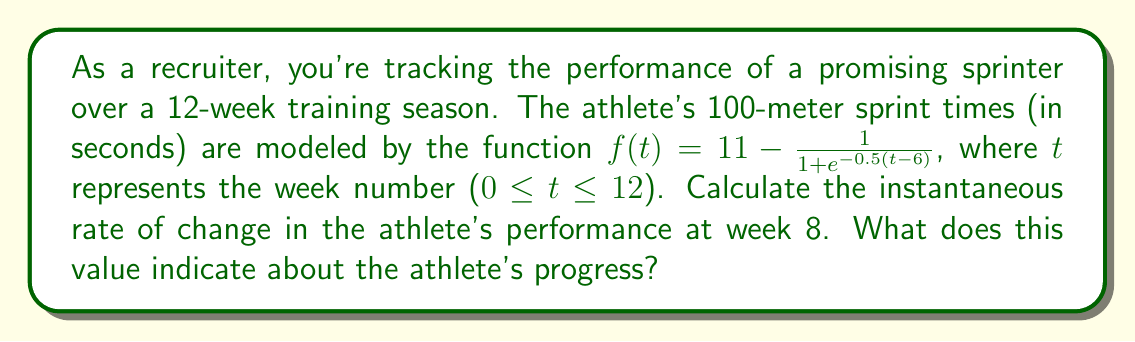What is the answer to this math problem? To solve this problem, we need to find the derivative of the given function and evaluate it at t = 8. This will give us the instantaneous rate of change at week 8.

1) First, let's find the derivative of $f(t)$:

   $f(t) = 11 - \frac{1}{1 + e^{-0.5(t-6)}}$

   Using the chain rule, we get:

   $$f'(t) = - \left(-\frac{1}{(1 + e^{-0.5(t-6)})^2} \cdot e^{-0.5(t-6)} \cdot (-0.5)\right)$$

   Simplifying:

   $$f'(t) = \frac{0.5e^{-0.5(t-6)}}{(1 + e^{-0.5(t-6)})^2}$$

2) Now, we need to evaluate $f'(8)$:

   $$f'(8) = \frac{0.5e^{-0.5(8-6)}}{(1 + e^{-0.5(8-6)})^2}$$

   $$= \frac{0.5e^{-1}}{(1 + e^{-1})^2}$$

3) Let's calculate this value:

   $e^{-1} \approx 0.3679$

   $$f'(8) = \frac{0.5 \cdot 0.3679}{(1 + 0.3679)^2} \approx 0.0874$$

4) Interpretation:
   The value is positive, indicating that the athlete's performance is still improving at week 8. The rate of improvement is approximately 0.0874 seconds per week, meaning the athlete is getting faster by about 0.0874 seconds each week at this point in the season.
Answer: The instantaneous rate of change at week 8 is approximately -0.0874 seconds per week. The negative sign indicates improvement (faster times) at a rate of about 0.0874 seconds per week. 